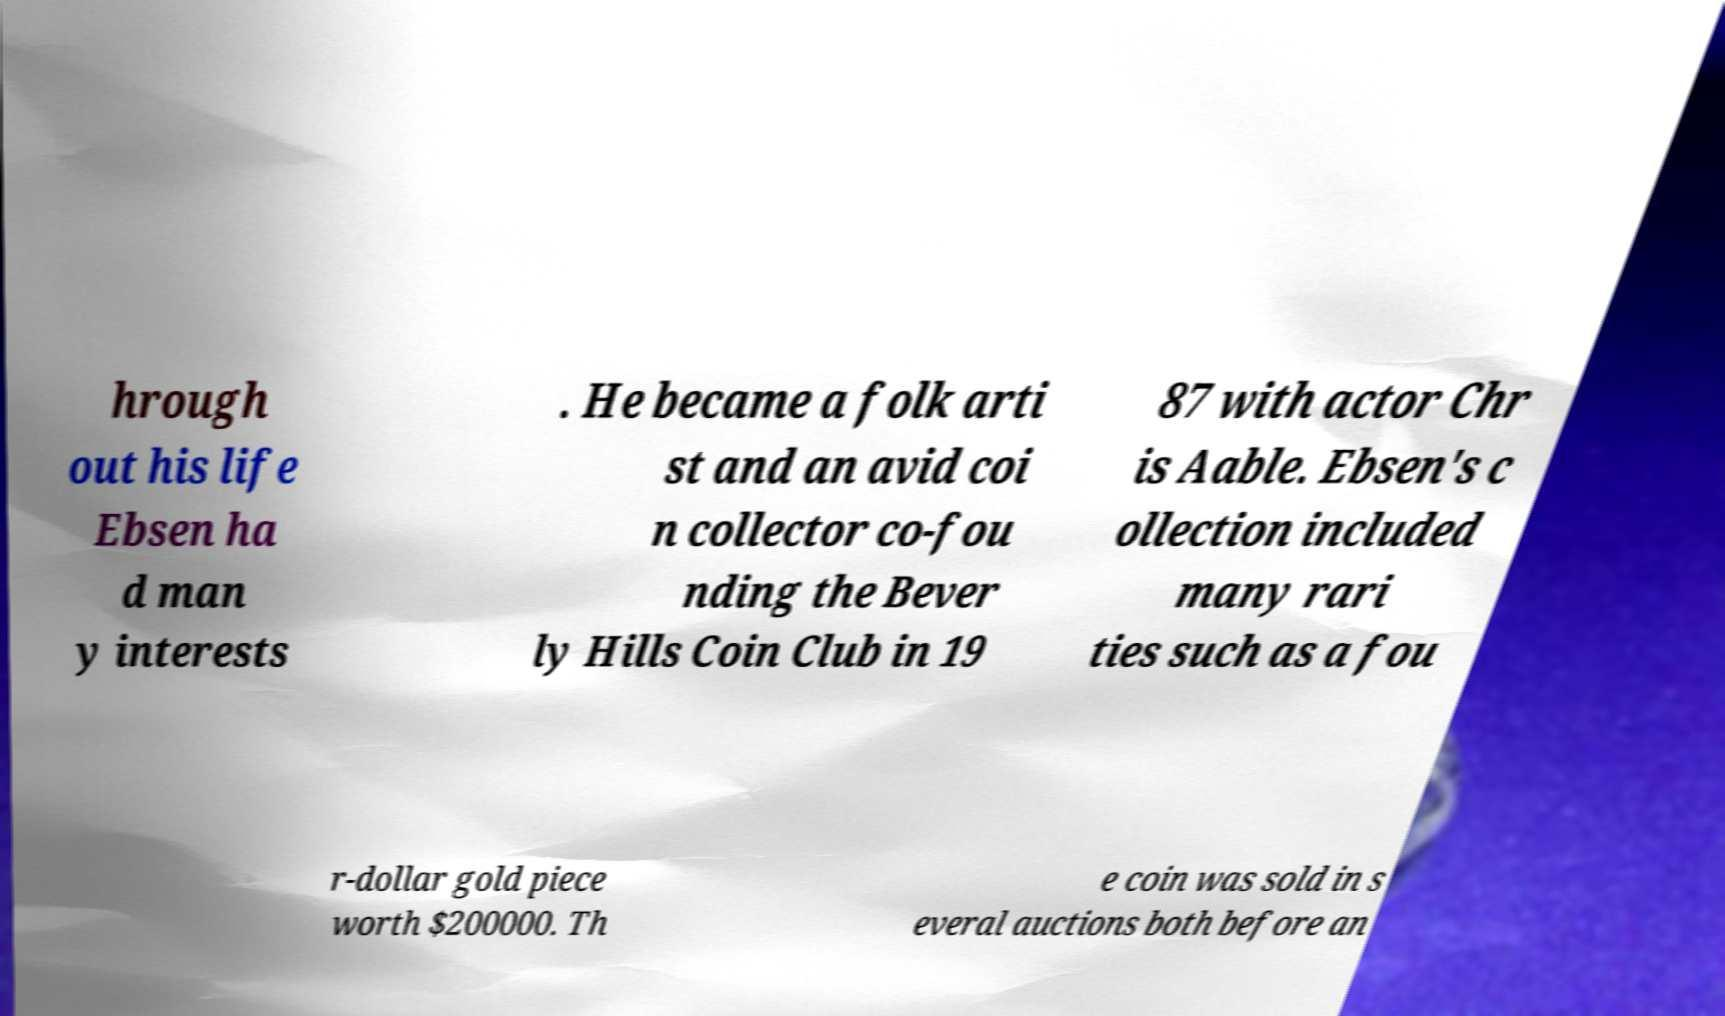What messages or text are displayed in this image? I need them in a readable, typed format. hrough out his life Ebsen ha d man y interests . He became a folk arti st and an avid coi n collector co-fou nding the Bever ly Hills Coin Club in 19 87 with actor Chr is Aable. Ebsen's c ollection included many rari ties such as a fou r-dollar gold piece worth $200000. Th e coin was sold in s everal auctions both before an 